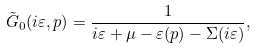<formula> <loc_0><loc_0><loc_500><loc_500>\tilde { G } _ { 0 } ( i \varepsilon , { p } ) = \frac { 1 } { i \varepsilon + \mu - \varepsilon ( { p } ) - \Sigma ( i \varepsilon ) } ,</formula> 